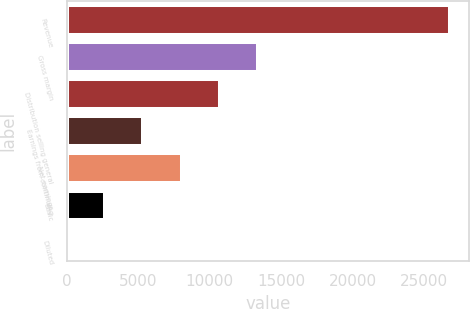<chart> <loc_0><loc_0><loc_500><loc_500><bar_chart><fcel>Revenue<fcel>Gross margin<fcel>Distribution selling general<fcel>Earnings from continuing<fcel>Net earnings<fcel>Basic<fcel>Diluted<nl><fcel>26792<fcel>13396.3<fcel>10717.2<fcel>5358.94<fcel>8038.07<fcel>2679.81<fcel>0.68<nl></chart> 